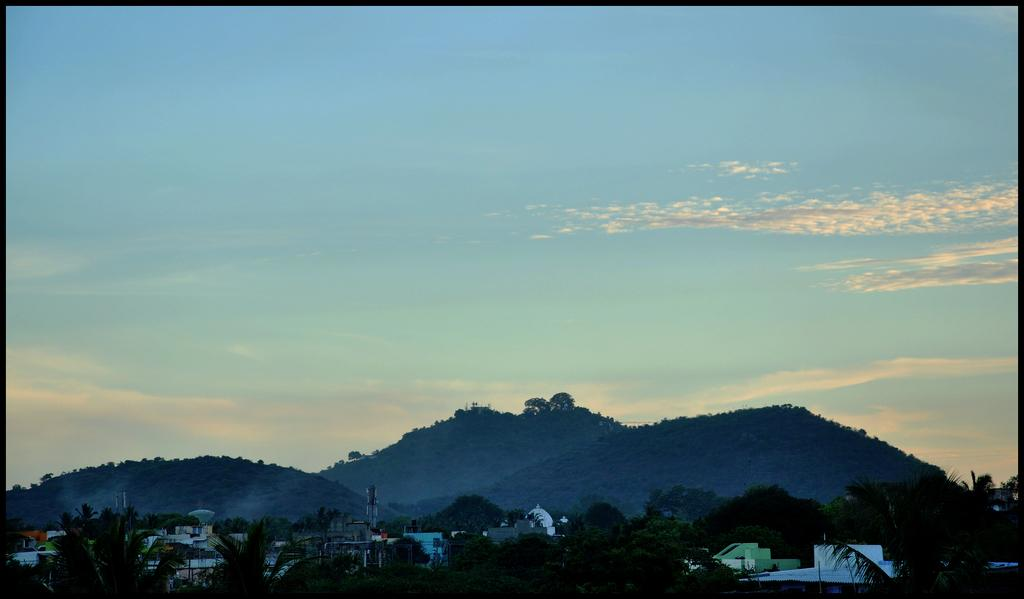What can be seen at the bottom of the picture? There are trees, buildings, cell phone towers, and hills at the bottom of the picture. What is the terrain like at the bottom of the picture? The hills are covered with trees. What is visible in the background of the image? The background of the image is the sky. How many snails can be seen crawling on the trees in the image? There are no snails visible in the image; it features trees, buildings, cell phone towers, and hills at the bottom, with the sky as the background. What type of wool is used to cover the hills in the image? There is no wool present in the image; the hills are covered with trees. 